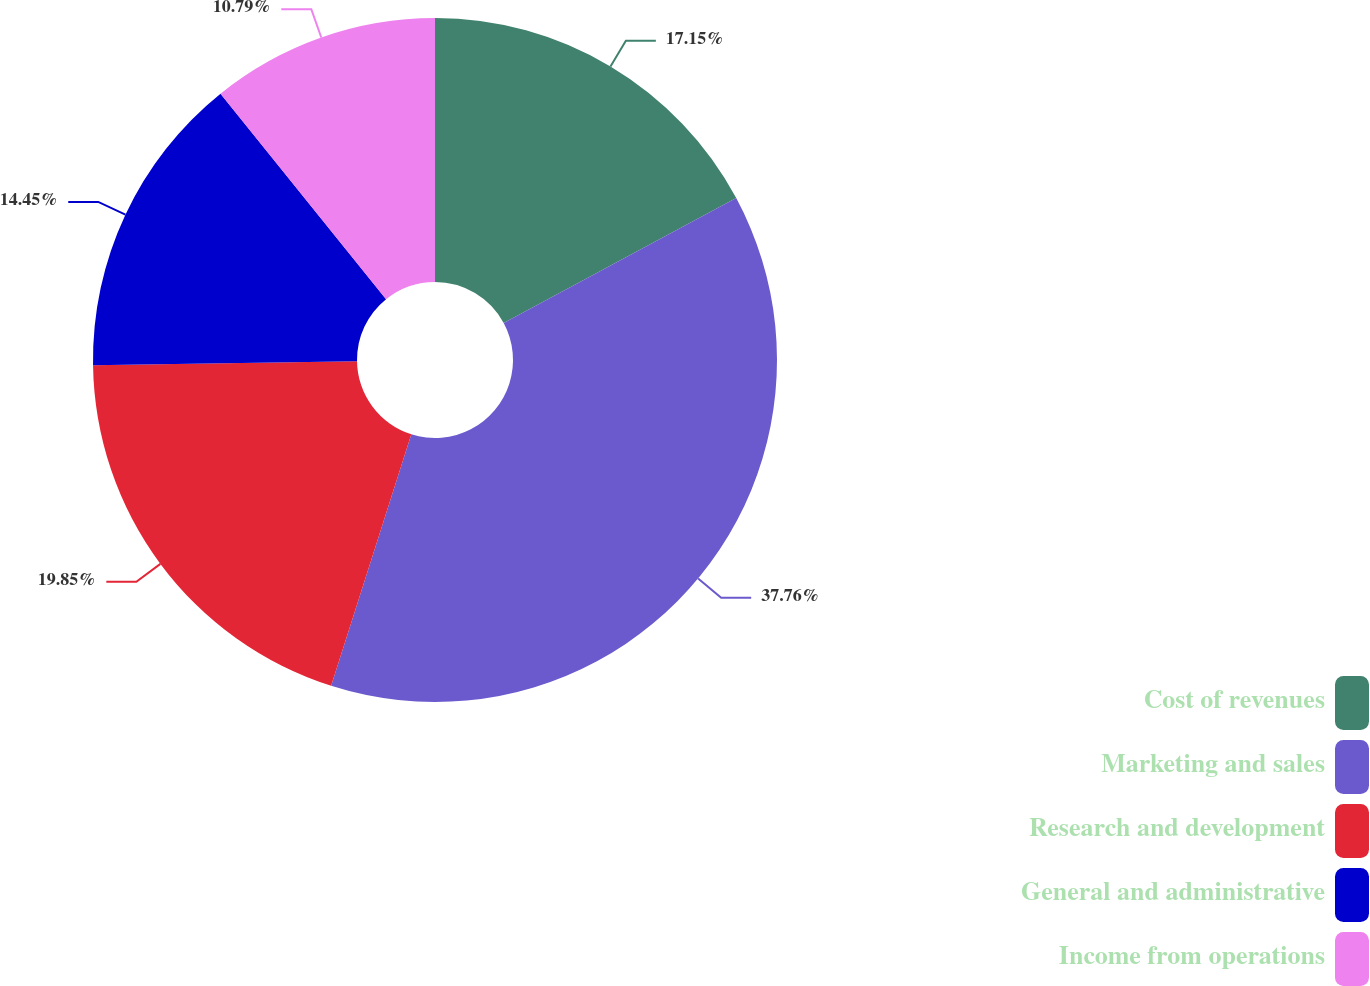Convert chart. <chart><loc_0><loc_0><loc_500><loc_500><pie_chart><fcel>Cost of revenues<fcel>Marketing and sales<fcel>Research and development<fcel>General and administrative<fcel>Income from operations<nl><fcel>17.15%<fcel>37.76%<fcel>19.85%<fcel>14.45%<fcel>10.79%<nl></chart> 